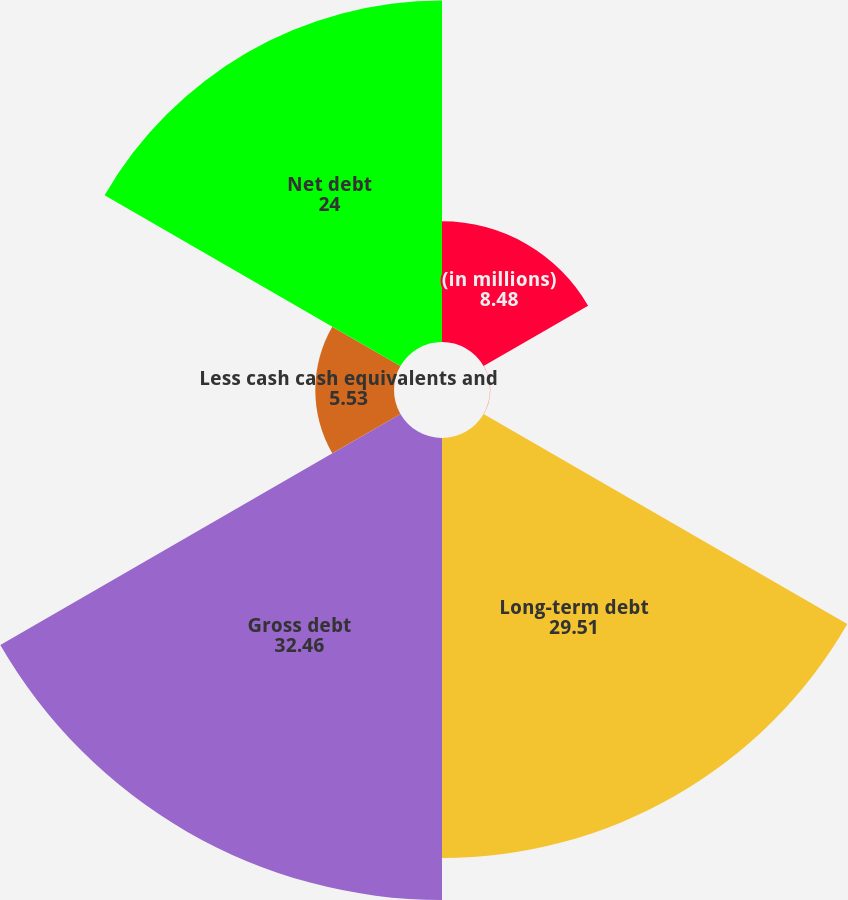<chart> <loc_0><loc_0><loc_500><loc_500><pie_chart><fcel>(in millions)<fcel>Short-term debt<fcel>Long-term debt<fcel>Gross debt<fcel>Less cash cash equivalents and<fcel>Net debt<nl><fcel>8.48%<fcel>0.02%<fcel>29.51%<fcel>32.46%<fcel>5.53%<fcel>24.0%<nl></chart> 